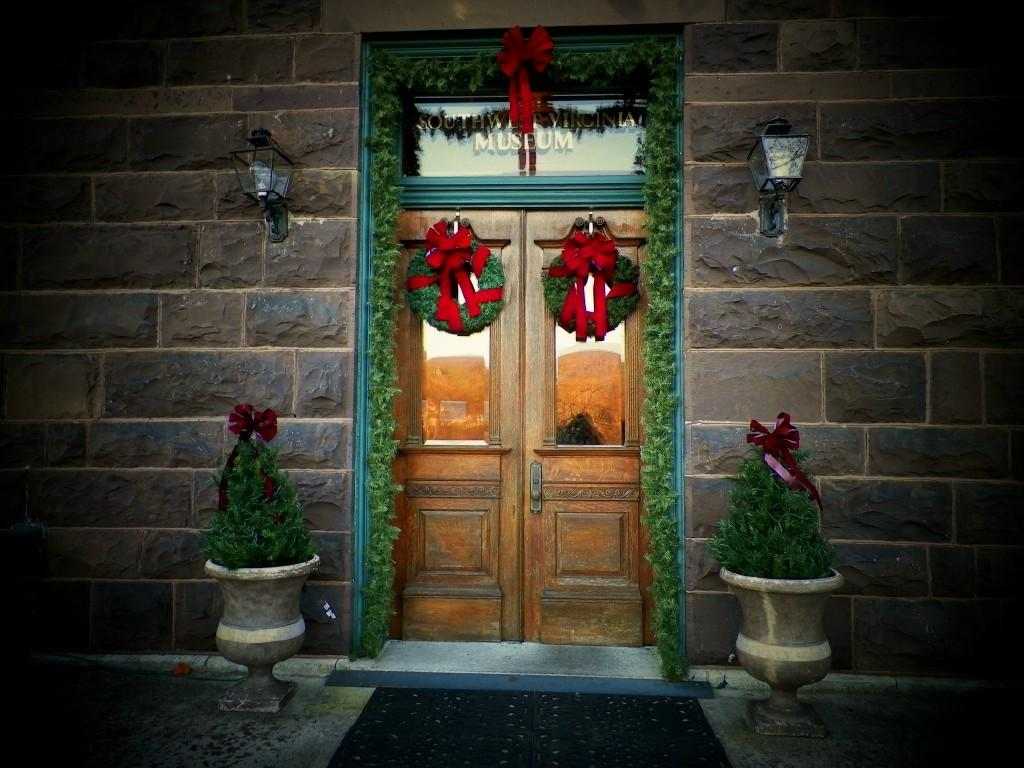What is one of the main features of the image? There is a wall in the image. What color are the doors on the wall? The doors in the image are brown-colored. What type of living organisms can be seen in the image? There are plants in the image. What decorative items can be seen in the image? There are ribbons in the image. What color is associated with some of the objects in the image? There are green-colored things in the image. What is attached to the wall in the image? There are lights on the wall in the image. What is the name of the daughter who is playing with the leather ball in the image? There is no daughter or leather ball present in the image. 